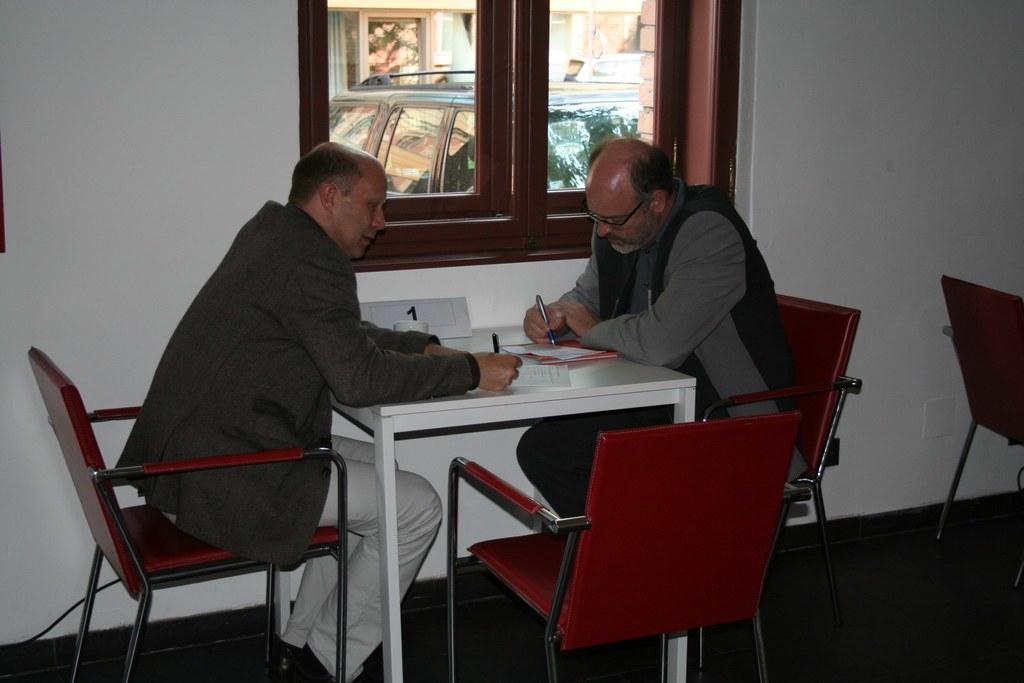Please provide a concise description of this image. In this image I see 2 men who are sitting on chairs and both of them are holding pens and there is a paper in front of them and in the background I see the wall, a window, a car through the window glass and chairs over here. 